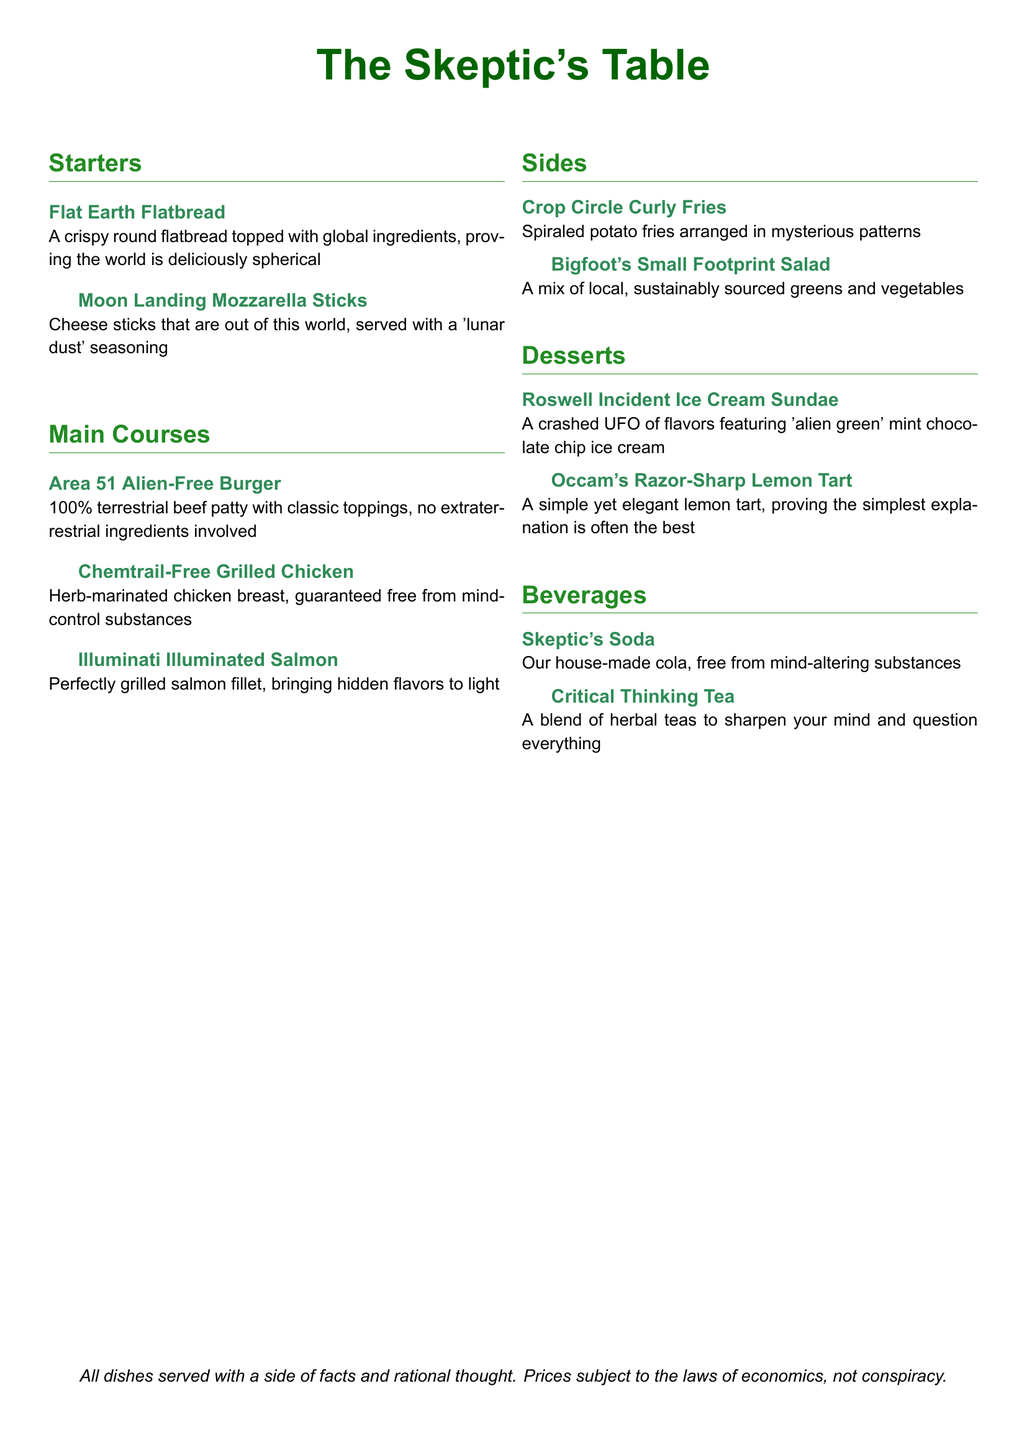What is the name of the dessert featuring mint chocolate chip ice cream? The dessert is named after an event involving a crashed UFO, which is humorously called the Roswell Incident Sundae.
Answer: Roswell Incident Ice Cream Sundae What type of meat is used in the Area 51 Alien-Free Burger? The burger is made with a specific type of beef, which is terrestrial beef, clearly indicating no alien ingredients are included.
Answer: 100% terrestrial beef patty What is the main ingredient in the Chemtrail-Free Grilled Chicken? The dish is primarily made with a marinated chicken breast, indicating its core ingredient.
Answer: Chicken breast What type of tea is served as a beverage? The beverage menu includes a type of herbal tea intended to enhance critical thinking abilities.
Answer: Critical Thinking Tea How many starters are listed on the menu? The menu features a total of two dishes under the starters section.
Answer: 2 Which side dish is named after a cryptid? The side dish that references a mythical creature in its name is specifically about a large, elusive ape.
Answer: Bigfoot's Small Footprint Salad What color is used for the title of the menu? The title of the menu uses a specific shade of green which is indicated in the document.
Answer: Green What type of fries are served as a side item? The fries served as a side dish are specifically shaped and grouped in a circular spiraled manner.
Answer: Curly Fries What is the dessert that emphasizes simplicity? The dessert emphasizes simplicity in its design, named after a principle related to reasoning.
Answer: Occam's Razor-Sharp Lemon Tart 